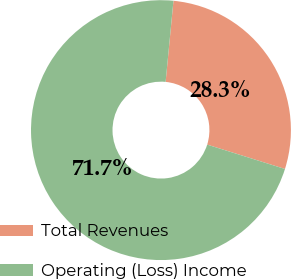Convert chart. <chart><loc_0><loc_0><loc_500><loc_500><pie_chart><fcel>Total Revenues<fcel>Operating (Loss) Income<nl><fcel>28.3%<fcel>71.7%<nl></chart> 